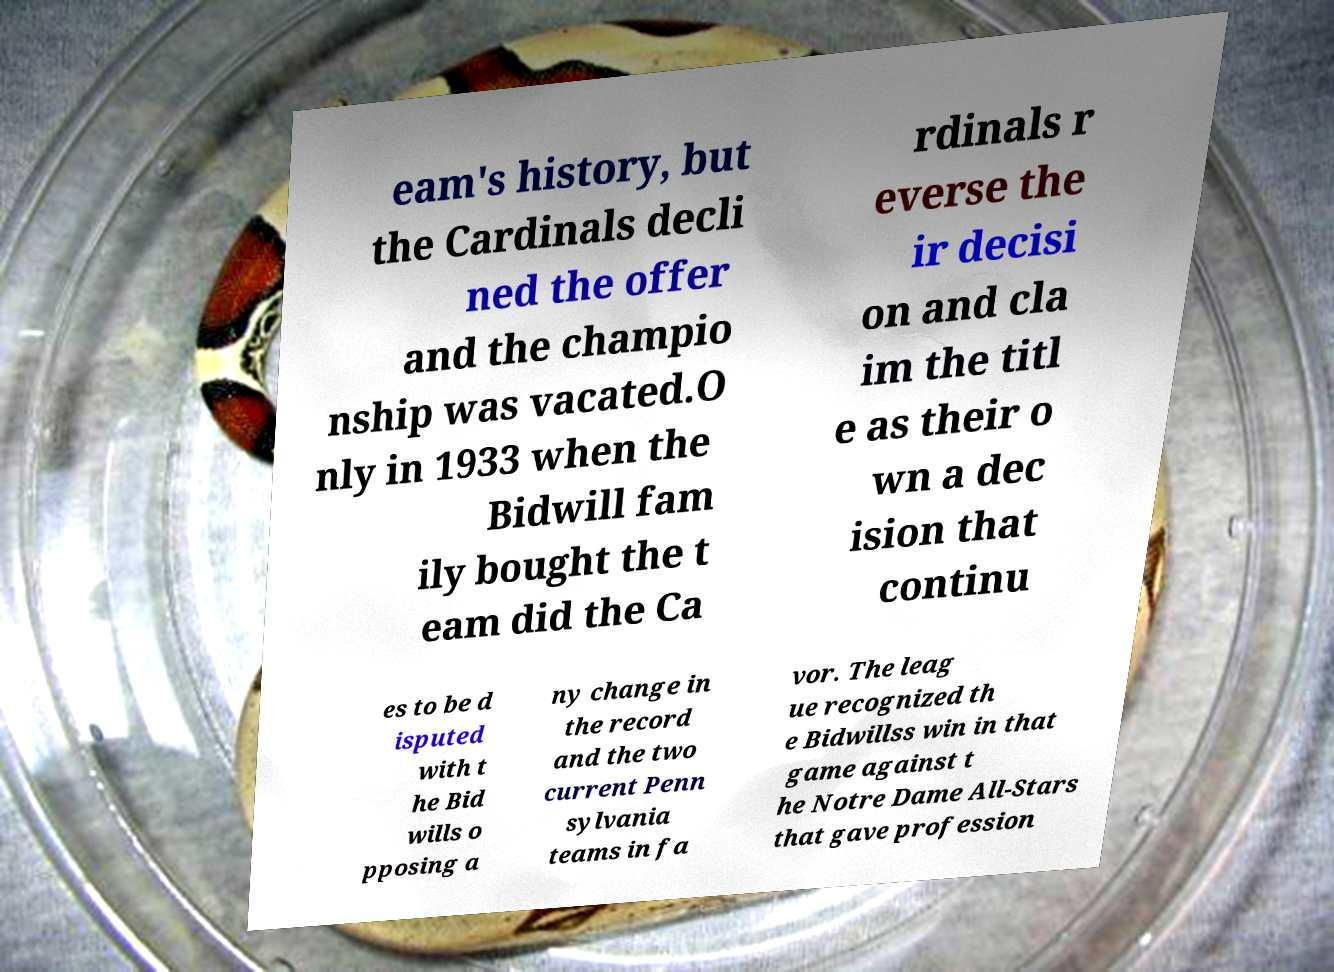Can you read and provide the text displayed in the image?This photo seems to have some interesting text. Can you extract and type it out for me? eam's history, but the Cardinals decli ned the offer and the champio nship was vacated.O nly in 1933 when the Bidwill fam ily bought the t eam did the Ca rdinals r everse the ir decisi on and cla im the titl e as their o wn a dec ision that continu es to be d isputed with t he Bid wills o pposing a ny change in the record and the two current Penn sylvania teams in fa vor. The leag ue recognized th e Bidwillss win in that game against t he Notre Dame All-Stars that gave profession 